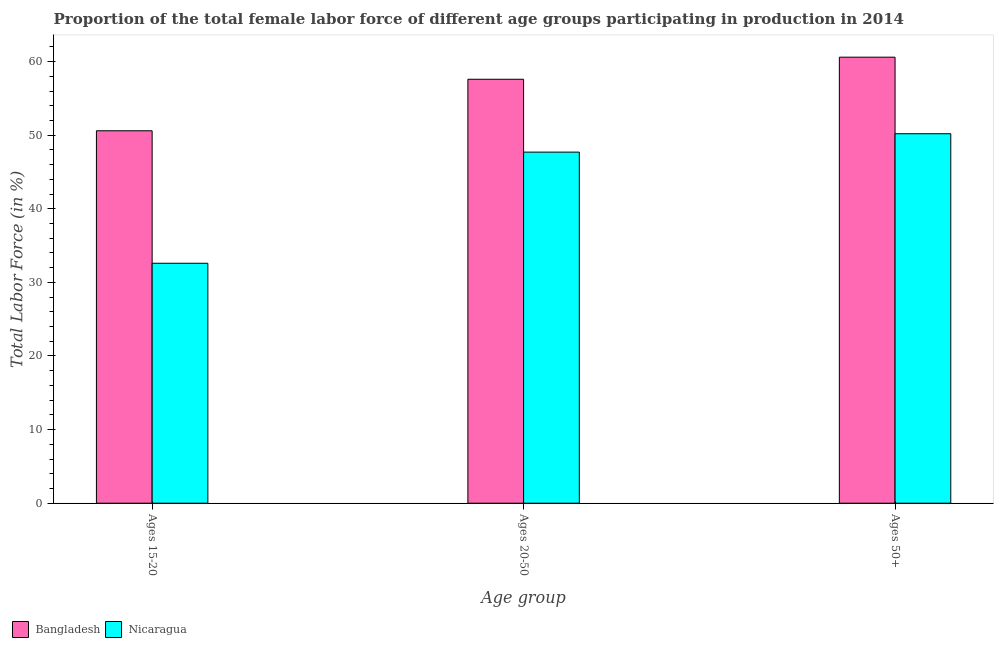How many groups of bars are there?
Give a very brief answer. 3. What is the label of the 3rd group of bars from the left?
Provide a succinct answer. Ages 50+. What is the percentage of female labor force within the age group 20-50 in Bangladesh?
Make the answer very short. 57.6. Across all countries, what is the maximum percentage of female labor force within the age group 15-20?
Make the answer very short. 50.6. Across all countries, what is the minimum percentage of female labor force within the age group 20-50?
Your answer should be compact. 47.7. In which country was the percentage of female labor force within the age group 15-20 minimum?
Your response must be concise. Nicaragua. What is the total percentage of female labor force within the age group 15-20 in the graph?
Provide a short and direct response. 83.2. What is the difference between the percentage of female labor force above age 50 in Bangladesh and that in Nicaragua?
Your answer should be very brief. 10.4. What is the average percentage of female labor force within the age group 15-20 per country?
Provide a short and direct response. 41.6. What is the difference between the percentage of female labor force within the age group 20-50 and percentage of female labor force above age 50 in Bangladesh?
Offer a terse response. -3. In how many countries, is the percentage of female labor force within the age group 15-20 greater than 52 %?
Your answer should be compact. 0. What is the ratio of the percentage of female labor force within the age group 20-50 in Nicaragua to that in Bangladesh?
Offer a very short reply. 0.83. What is the difference between the highest and the second highest percentage of female labor force within the age group 20-50?
Your answer should be very brief. 9.9. What is the difference between the highest and the lowest percentage of female labor force within the age group 20-50?
Ensure brevity in your answer.  9.9. How many bars are there?
Provide a succinct answer. 6. What is the difference between two consecutive major ticks on the Y-axis?
Provide a succinct answer. 10. Are the values on the major ticks of Y-axis written in scientific E-notation?
Provide a short and direct response. No. Does the graph contain any zero values?
Your answer should be very brief. No. Where does the legend appear in the graph?
Your answer should be compact. Bottom left. What is the title of the graph?
Your answer should be compact. Proportion of the total female labor force of different age groups participating in production in 2014. What is the label or title of the X-axis?
Keep it short and to the point. Age group. What is the label or title of the Y-axis?
Your response must be concise. Total Labor Force (in %). What is the Total Labor Force (in %) in Bangladesh in Ages 15-20?
Your answer should be compact. 50.6. What is the Total Labor Force (in %) of Nicaragua in Ages 15-20?
Make the answer very short. 32.6. What is the Total Labor Force (in %) of Bangladesh in Ages 20-50?
Your answer should be very brief. 57.6. What is the Total Labor Force (in %) of Nicaragua in Ages 20-50?
Your response must be concise. 47.7. What is the Total Labor Force (in %) of Bangladesh in Ages 50+?
Provide a short and direct response. 60.6. What is the Total Labor Force (in %) in Nicaragua in Ages 50+?
Your response must be concise. 50.2. Across all Age group, what is the maximum Total Labor Force (in %) of Bangladesh?
Make the answer very short. 60.6. Across all Age group, what is the maximum Total Labor Force (in %) of Nicaragua?
Your answer should be very brief. 50.2. Across all Age group, what is the minimum Total Labor Force (in %) in Bangladesh?
Your response must be concise. 50.6. Across all Age group, what is the minimum Total Labor Force (in %) in Nicaragua?
Provide a short and direct response. 32.6. What is the total Total Labor Force (in %) in Bangladesh in the graph?
Ensure brevity in your answer.  168.8. What is the total Total Labor Force (in %) in Nicaragua in the graph?
Provide a succinct answer. 130.5. What is the difference between the Total Labor Force (in %) in Nicaragua in Ages 15-20 and that in Ages 20-50?
Keep it short and to the point. -15.1. What is the difference between the Total Labor Force (in %) in Nicaragua in Ages 15-20 and that in Ages 50+?
Your response must be concise. -17.6. What is the difference between the Total Labor Force (in %) in Bangladesh in Ages 15-20 and the Total Labor Force (in %) in Nicaragua in Ages 20-50?
Offer a very short reply. 2.9. What is the average Total Labor Force (in %) in Bangladesh per Age group?
Keep it short and to the point. 56.27. What is the average Total Labor Force (in %) in Nicaragua per Age group?
Offer a very short reply. 43.5. What is the difference between the Total Labor Force (in %) of Bangladesh and Total Labor Force (in %) of Nicaragua in Ages 15-20?
Provide a succinct answer. 18. What is the ratio of the Total Labor Force (in %) of Bangladesh in Ages 15-20 to that in Ages 20-50?
Your response must be concise. 0.88. What is the ratio of the Total Labor Force (in %) in Nicaragua in Ages 15-20 to that in Ages 20-50?
Your answer should be compact. 0.68. What is the ratio of the Total Labor Force (in %) of Bangladesh in Ages 15-20 to that in Ages 50+?
Ensure brevity in your answer.  0.83. What is the ratio of the Total Labor Force (in %) in Nicaragua in Ages 15-20 to that in Ages 50+?
Offer a very short reply. 0.65. What is the ratio of the Total Labor Force (in %) in Bangladesh in Ages 20-50 to that in Ages 50+?
Provide a short and direct response. 0.95. What is the ratio of the Total Labor Force (in %) of Nicaragua in Ages 20-50 to that in Ages 50+?
Your answer should be very brief. 0.95. What is the difference between the highest and the second highest Total Labor Force (in %) of Bangladesh?
Offer a very short reply. 3. 